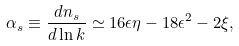<formula> <loc_0><loc_0><loc_500><loc_500>\alpha _ { s } \equiv \frac { d n _ { s } } { d \ln k } \simeq 1 6 \epsilon \eta - 1 8 \epsilon ^ { 2 } - 2 \xi ,</formula> 